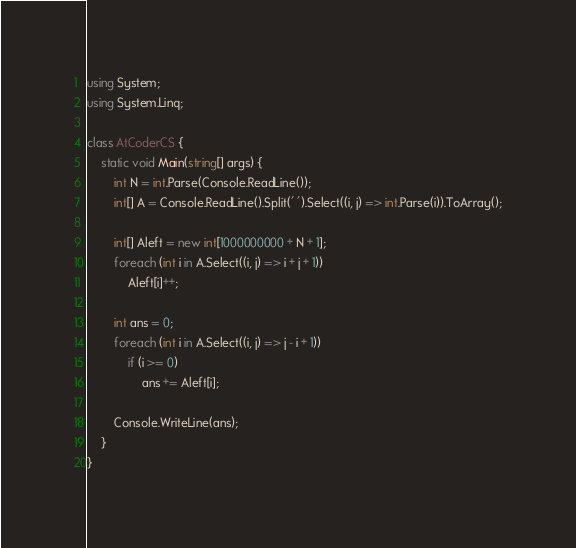Convert code to text. <code><loc_0><loc_0><loc_500><loc_500><_C#_>using System;
using System.Linq;

class AtCoderCS {
    static void Main(string[] args) {
        int N = int.Parse(Console.ReadLine());
        int[] A = Console.ReadLine().Split(' ').Select((i, j) => int.Parse(i)).ToArray();

        int[] Aleft = new int[1000000000 + N + 1];
        foreach (int i in A.Select((i, j) => i + j + 1))
            Aleft[i]++;

        int ans = 0;
        foreach (int i in A.Select((i, j) => j - i + 1))
            if (i >= 0)
                ans += Aleft[i];

        Console.WriteLine(ans);
    }
}</code> 